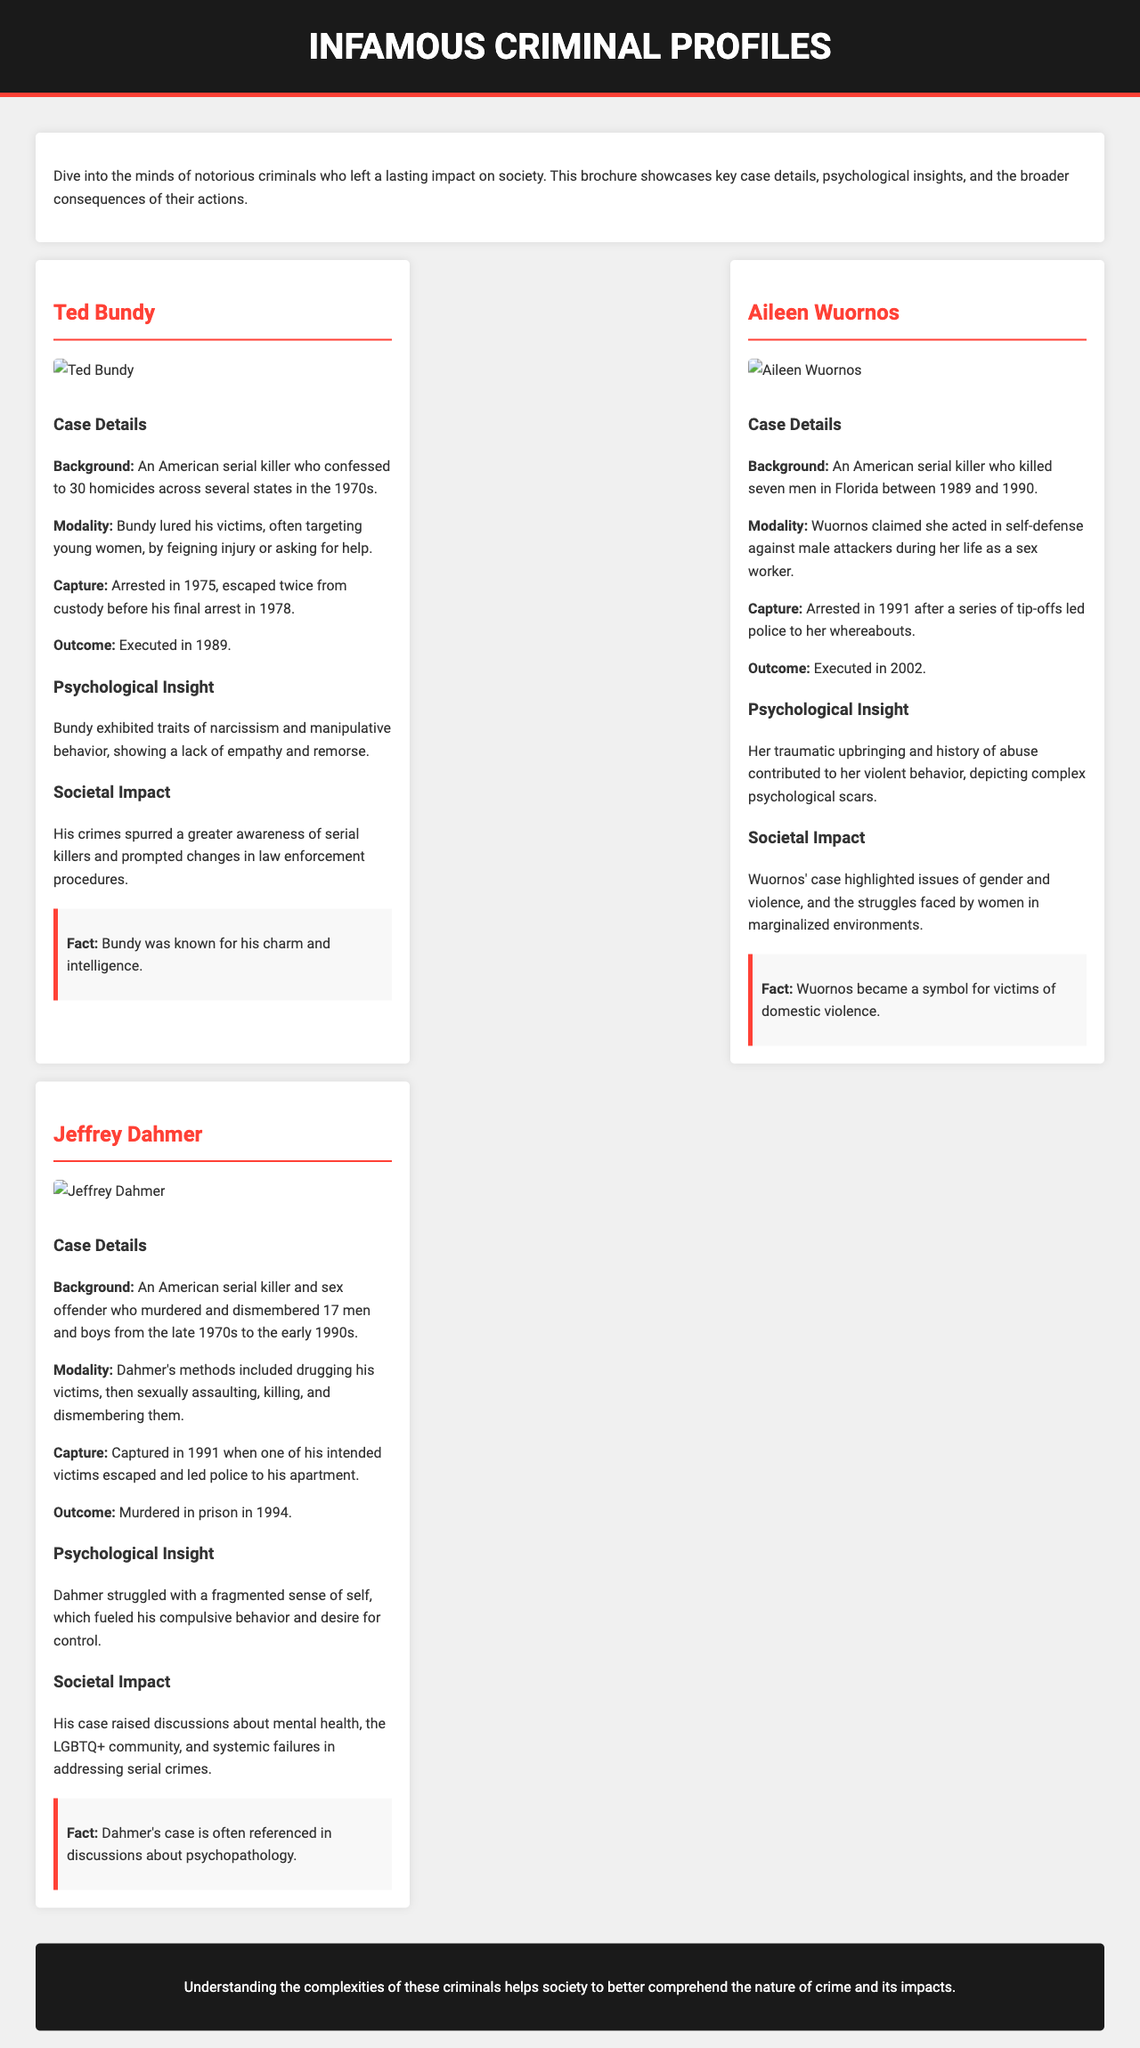what is the title of the brochure? The title of the brochure is prominently displayed at the top of the document.
Answer: Infamous Criminal Profiles who is the first criminal profile featured? The first profile in the brochure highlights a prominent criminal.
Answer: Ted Bundy how many homicides did Ted Bundy confess to? This detail can be found in the case details section of Bundy's profile.
Answer: 30 what was Aileen Wuornos' outcome? This information is included in the summary of Wuornos' profile.
Answer: Executed in 2002 which psychological trait is associated with Jeffrey Dahmer? The psychological insight section lists traits related to Dahmer’s behavior.
Answer: Fragmented sense of self what year did Jeffrey Dahmer get captured? This can be determined from the case details provided in Dahmer's profile.
Answer: 1991 what is the societal impact of Bundy's crimes? This impact is discussed in Bundy's profile and highlights broader societal changes.
Answer: Greater awareness of serial killers how many men did Aileen Wuornos kill? This figure is mentioned in the background details of Wuornos' profile.
Answer: Seven what visual element accompanies each criminal's profile? The document format includes specific visual aids to enhance information.
Answer: Images 